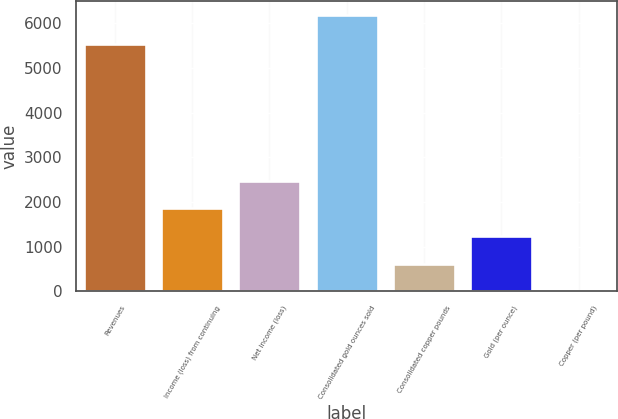<chart> <loc_0><loc_0><loc_500><loc_500><bar_chart><fcel>Revenues<fcel>Income (loss) from continuing<fcel>Net income (loss)<fcel>Consolidated gold ounces sold<fcel>Consolidated copper pounds<fcel>Gold (per ounce)<fcel>Copper (per pound)<nl><fcel>5526<fcel>1857.19<fcel>2475.3<fcel>6184<fcel>620.97<fcel>1239.08<fcel>2.86<nl></chart> 